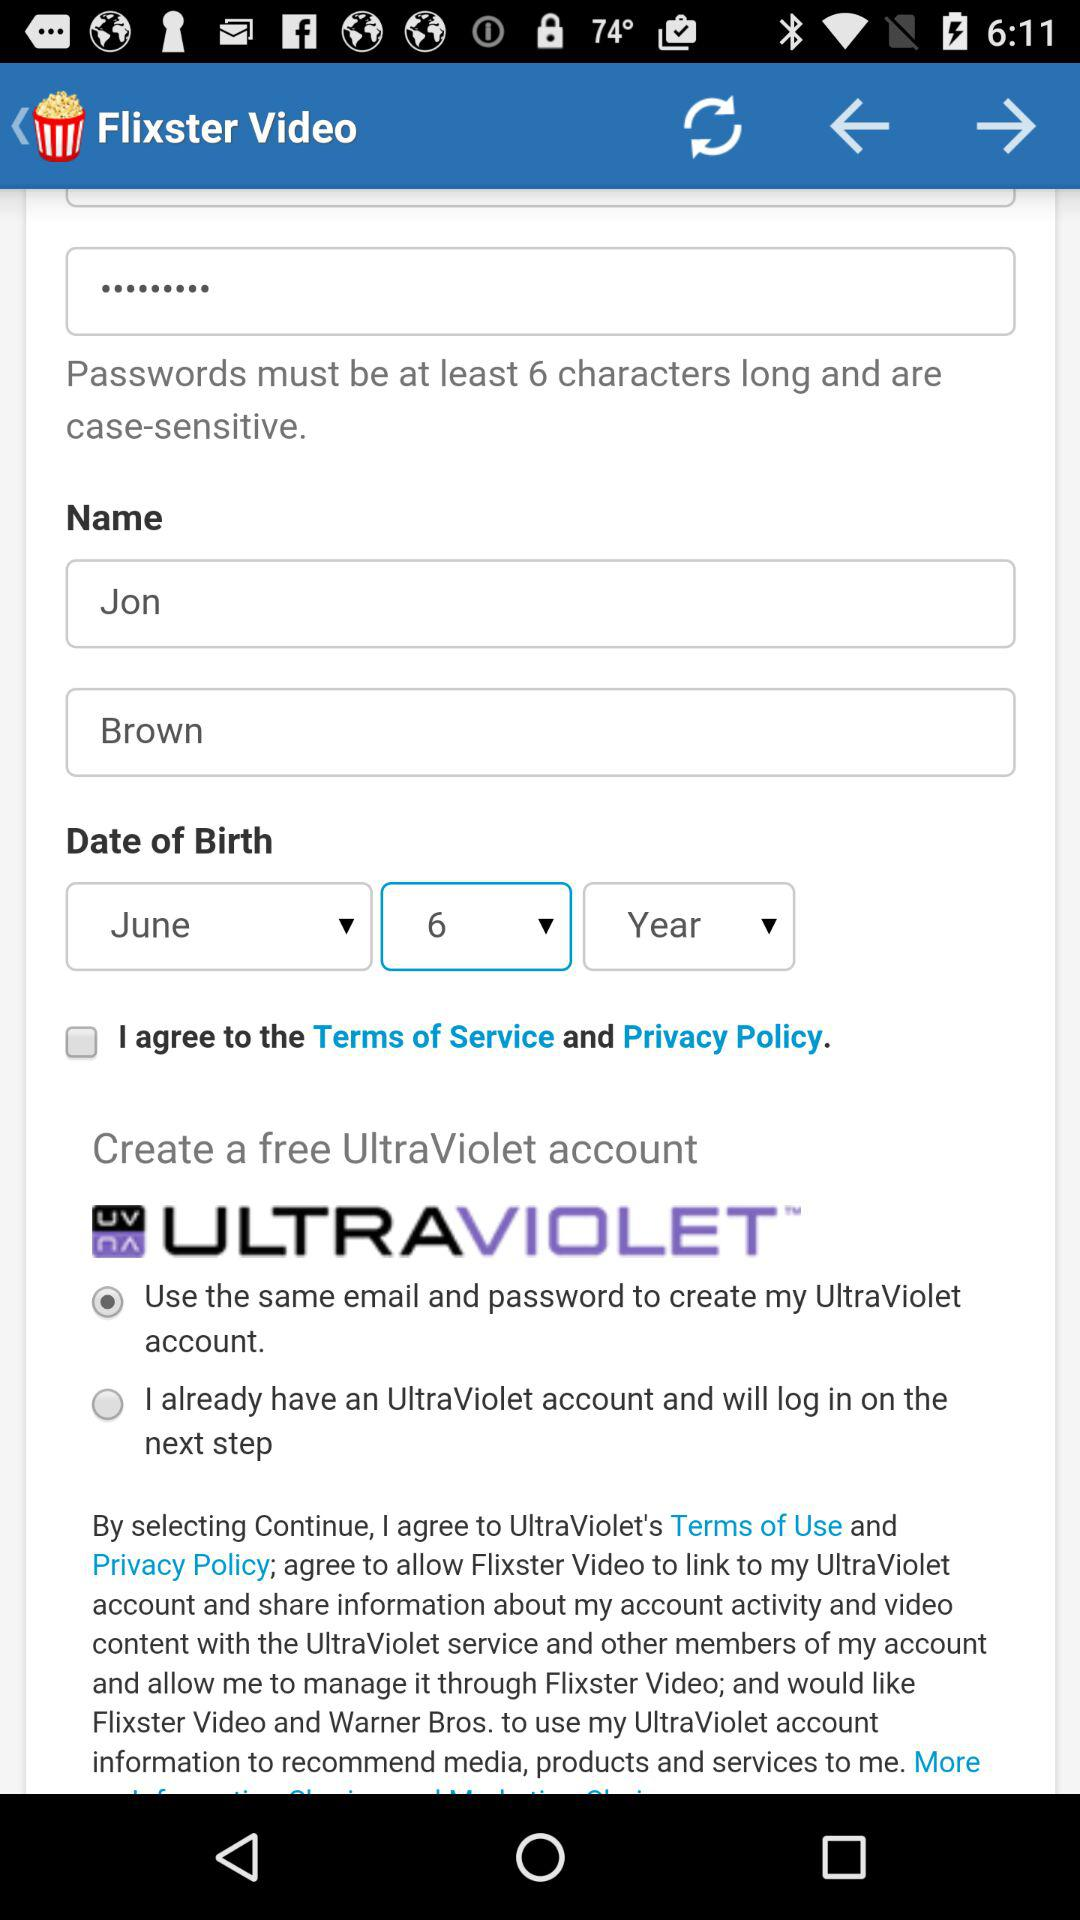What is the name of the user? The name of the user is "Jon Brown". 